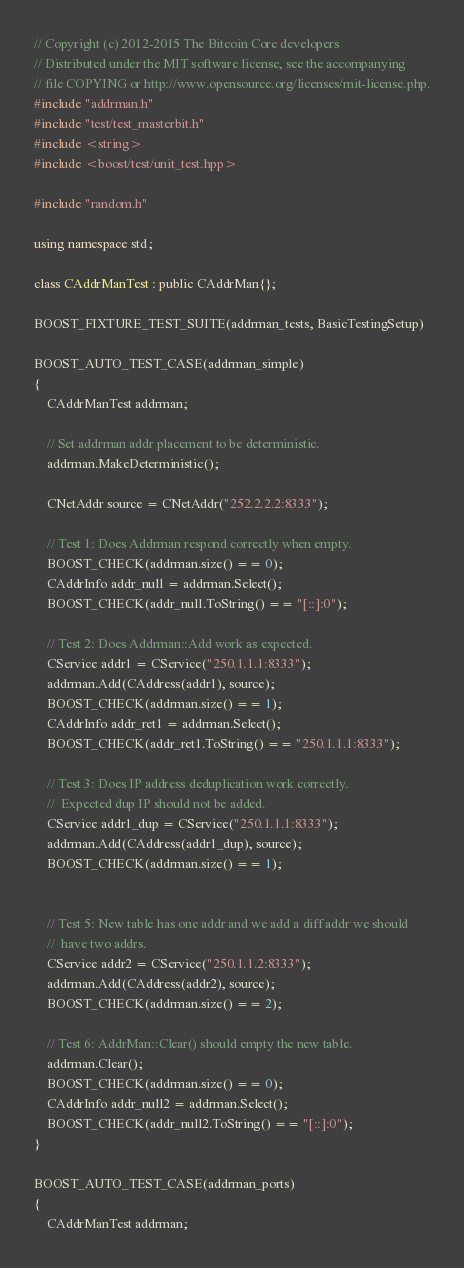<code> <loc_0><loc_0><loc_500><loc_500><_C++_>// Copyright (c) 2012-2015 The Bitcoin Core developers
// Distributed under the MIT software license, see the accompanying
// file COPYING or http://www.opensource.org/licenses/mit-license.php.
#include "addrman.h"
#include "test/test_masterbit.h"
#include <string>
#include <boost/test/unit_test.hpp>

#include "random.h"

using namespace std;

class CAddrManTest : public CAddrMan{};

BOOST_FIXTURE_TEST_SUITE(addrman_tests, BasicTestingSetup)

BOOST_AUTO_TEST_CASE(addrman_simple)
{
    CAddrManTest addrman;

    // Set addrman addr placement to be deterministic.
    addrman.MakeDeterministic();

    CNetAddr source = CNetAddr("252.2.2.2:8333");

    // Test 1: Does Addrman respond correctly when empty.
    BOOST_CHECK(addrman.size() == 0);
    CAddrInfo addr_null = addrman.Select();
    BOOST_CHECK(addr_null.ToString() == "[::]:0");

    // Test 2: Does Addrman::Add work as expected.
    CService addr1 = CService("250.1.1.1:8333");
    addrman.Add(CAddress(addr1), source);
    BOOST_CHECK(addrman.size() == 1);
    CAddrInfo addr_ret1 = addrman.Select();
    BOOST_CHECK(addr_ret1.ToString() == "250.1.1.1:8333");

    // Test 3: Does IP address deduplication work correctly. 
    //  Expected dup IP should not be added.
    CService addr1_dup = CService("250.1.1.1:8333");
    addrman.Add(CAddress(addr1_dup), source);
    BOOST_CHECK(addrman.size() == 1);


    // Test 5: New table has one addr and we add a diff addr we should
    //  have two addrs.
    CService addr2 = CService("250.1.1.2:8333");
    addrman.Add(CAddress(addr2), source);
    BOOST_CHECK(addrman.size() == 2);

    // Test 6: AddrMan::Clear() should empty the new table. 
    addrman.Clear();
    BOOST_CHECK(addrman.size() == 0);
    CAddrInfo addr_null2 = addrman.Select();
    BOOST_CHECK(addr_null2.ToString() == "[::]:0");
}

BOOST_AUTO_TEST_CASE(addrman_ports)
{
    CAddrManTest addrman;
</code> 